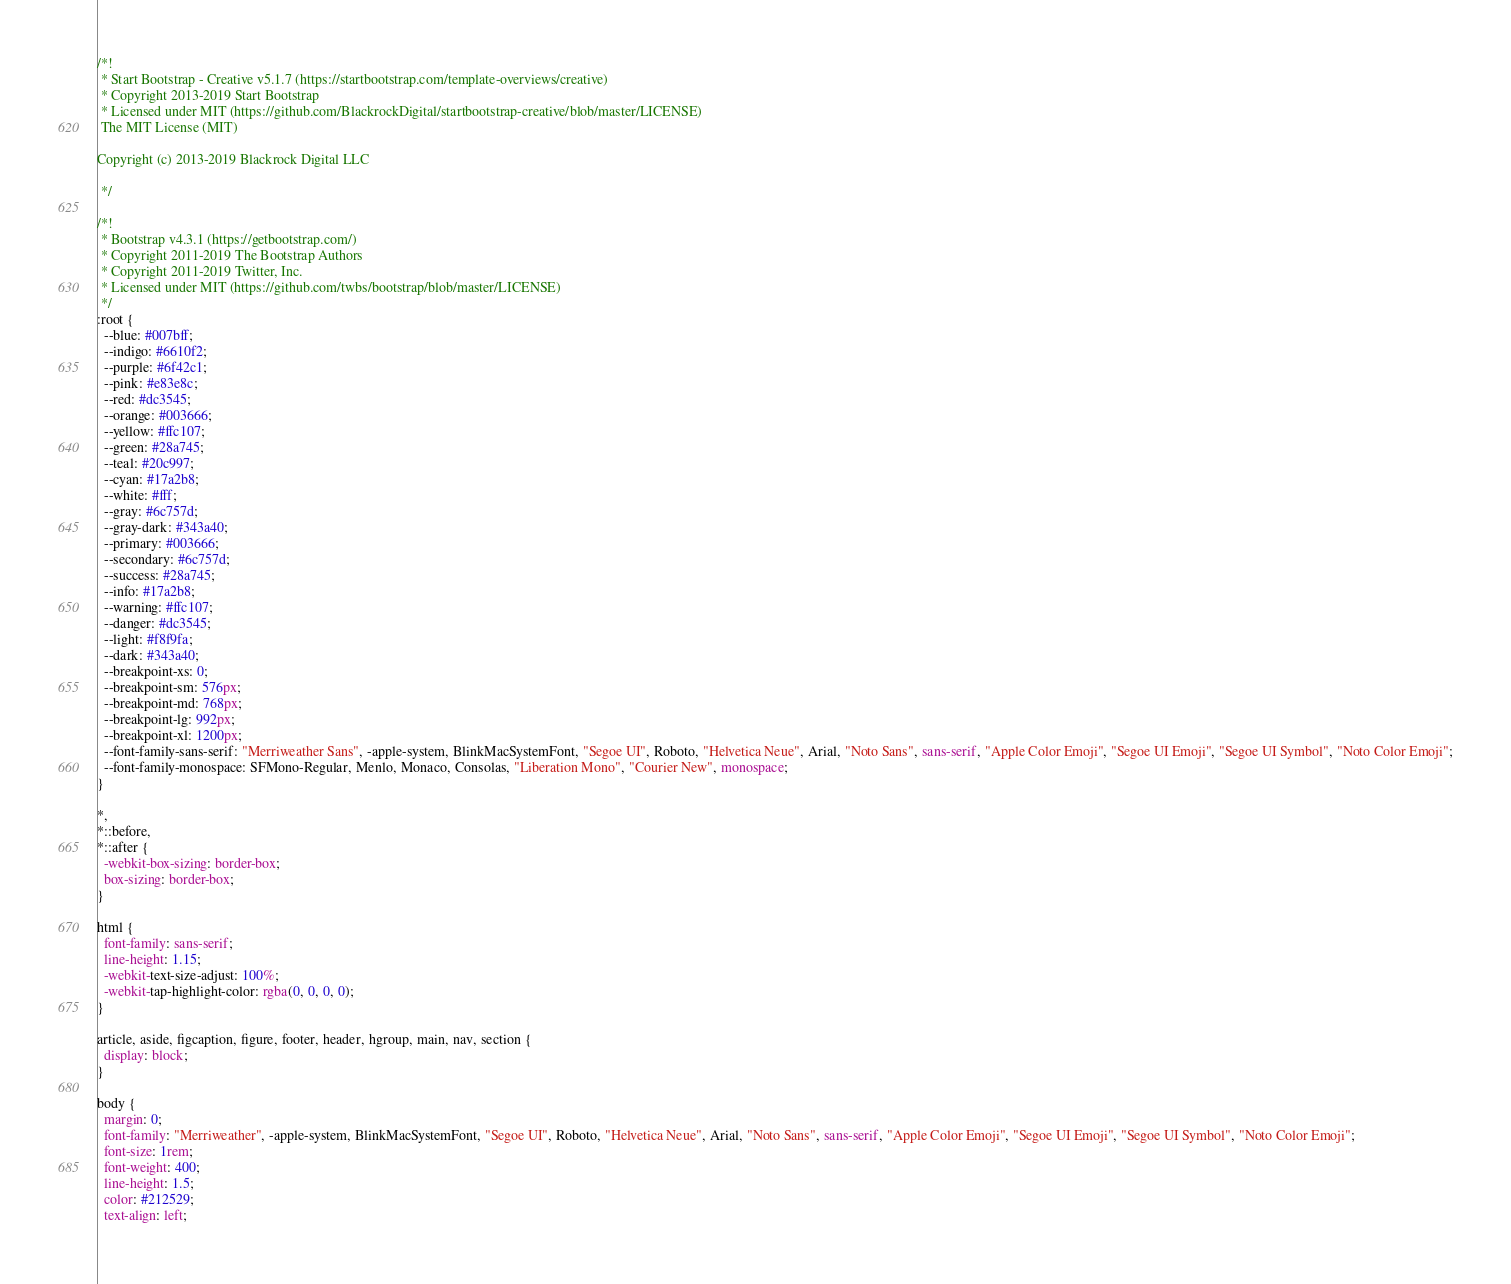Convert code to text. <code><loc_0><loc_0><loc_500><loc_500><_CSS_>/*!
 * Start Bootstrap - Creative v5.1.7 (https://startbootstrap.com/template-overviews/creative)
 * Copyright 2013-2019 Start Bootstrap
 * Licensed under MIT (https://github.com/BlackrockDigital/startbootstrap-creative/blob/master/LICENSE)
 The MIT License (MIT)

Copyright (c) 2013-2019 Blackrock Digital LLC

 */

/*!
 * Bootstrap v4.3.1 (https://getbootstrap.com/)
 * Copyright 2011-2019 The Bootstrap Authors
 * Copyright 2011-2019 Twitter, Inc.
 * Licensed under MIT (https://github.com/twbs/bootstrap/blob/master/LICENSE)
 */
:root {
  --blue: #007bff;
  --indigo: #6610f2;
  --purple: #6f42c1;
  --pink: #e83e8c;
  --red: #dc3545;
  --orange: #003666;
  --yellow: #ffc107;
  --green: #28a745;
  --teal: #20c997;
  --cyan: #17a2b8;
  --white: #fff;
  --gray: #6c757d;
  --gray-dark: #343a40;
  --primary: #003666;
  --secondary: #6c757d;
  --success: #28a745;
  --info: #17a2b8;
  --warning: #ffc107;
  --danger: #dc3545;
  --light: #f8f9fa;
  --dark: #343a40;
  --breakpoint-xs: 0;
  --breakpoint-sm: 576px;
  --breakpoint-md: 768px;
  --breakpoint-lg: 992px;
  --breakpoint-xl: 1200px;
  --font-family-sans-serif: "Merriweather Sans", -apple-system, BlinkMacSystemFont, "Segoe UI", Roboto, "Helvetica Neue", Arial, "Noto Sans", sans-serif, "Apple Color Emoji", "Segoe UI Emoji", "Segoe UI Symbol", "Noto Color Emoji";
  --font-family-monospace: SFMono-Regular, Menlo, Monaco, Consolas, "Liberation Mono", "Courier New", monospace;
}

*,
*::before,
*::after {
  -webkit-box-sizing: border-box;
  box-sizing: border-box;
}

html {
  font-family: sans-serif;
  line-height: 1.15;
  -webkit-text-size-adjust: 100%;
  -webkit-tap-highlight-color: rgba(0, 0, 0, 0);
}

article, aside, figcaption, figure, footer, header, hgroup, main, nav, section {
  display: block;
}

body {
  margin: 0;
  font-family: "Merriweather", -apple-system, BlinkMacSystemFont, "Segoe UI", Roboto, "Helvetica Neue", Arial, "Noto Sans", sans-serif, "Apple Color Emoji", "Segoe UI Emoji", "Segoe UI Symbol", "Noto Color Emoji";
  font-size: 1rem;
  font-weight: 400;
  line-height: 1.5;
  color: #212529;
  text-align: left;</code> 